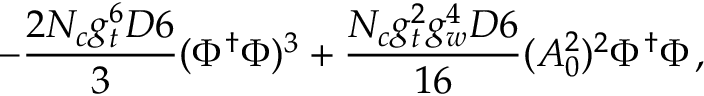Convert formula to latex. <formula><loc_0><loc_0><loc_500><loc_500>- \frac { 2 N _ { c } g _ { t } ^ { 6 } D 6 } { 3 } ( \Phi ^ { \dag } \Phi ) ^ { 3 } + \frac { N _ { c } g _ { t } ^ { 2 } g _ { w } ^ { 4 } D 6 } { 1 6 } ( A _ { 0 } ^ { 2 } ) ^ { 2 } \Phi ^ { \dag } \Phi \, ,</formula> 